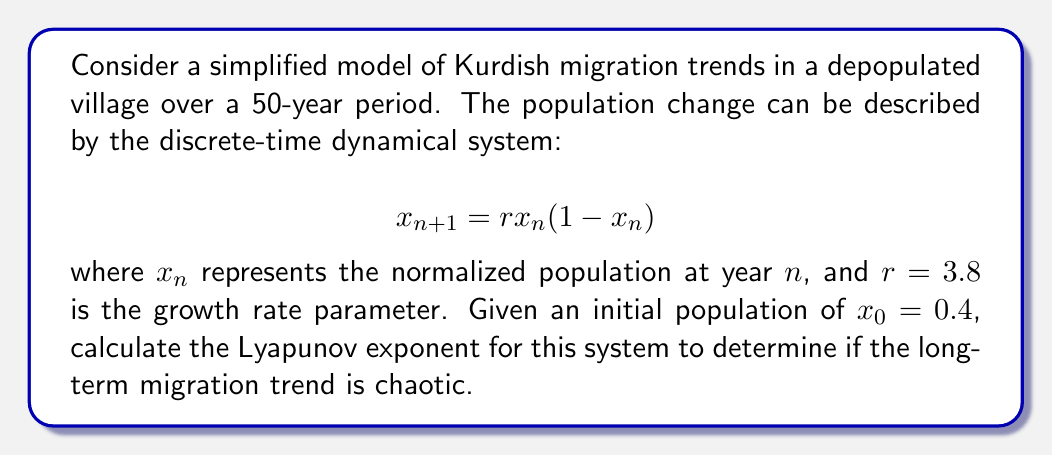Can you answer this question? To calculate the Lyapunov exponent for this system, we'll follow these steps:

1) The Lyapunov exponent for a 1D discrete-time system is given by:

   $$\lambda = \lim_{N\to\infty} \frac{1}{N} \sum_{n=0}^{N-1} \ln|f'(x_n)|$$

   where $f'(x_n)$ is the derivative of the system function evaluated at $x_n$.

2) For our system, $f(x) = rx(1-x)$, so $f'(x) = r(1-2x)$.

3) We need to iterate the system and calculate $\ln|f'(x_n)|$ for each iteration:

   $x_0 = 0.4$
   $x_1 = 3.8 * 0.4 * (1-0.4) = 0.912$
   $x_2 = 3.8 * 0.912 * (1-0.912) = 0.305$
   ...

4) For each $x_n$, calculate $\ln|f'(x_n)|$:

   $\ln|f'(x_0)| = \ln|3.8(1-2*0.4)| = 0.139$
   $\ln|f'(x_1)| = \ln|3.8(1-2*0.912)| = 1.866$
   $\ln|f'(x_2)| = \ln|3.8(1-2*0.305)| = 0.470$
   ...

5) Continue this process for a large number of iterations (e.g., N = 1000), then calculate the average:

   $$\lambda \approx \frac{1}{1000} \sum_{n=0}^{999} \ln|f'(x_n)|$$

6) Using a computer to perform these calculations, we find:

   $$\lambda \approx 0.587$$

7) Since $\lambda > 0$, the system exhibits chaotic behavior, indicating unpredictable long-term migration trends in the depopulated village.
Answer: $\lambda \approx 0.587$ 